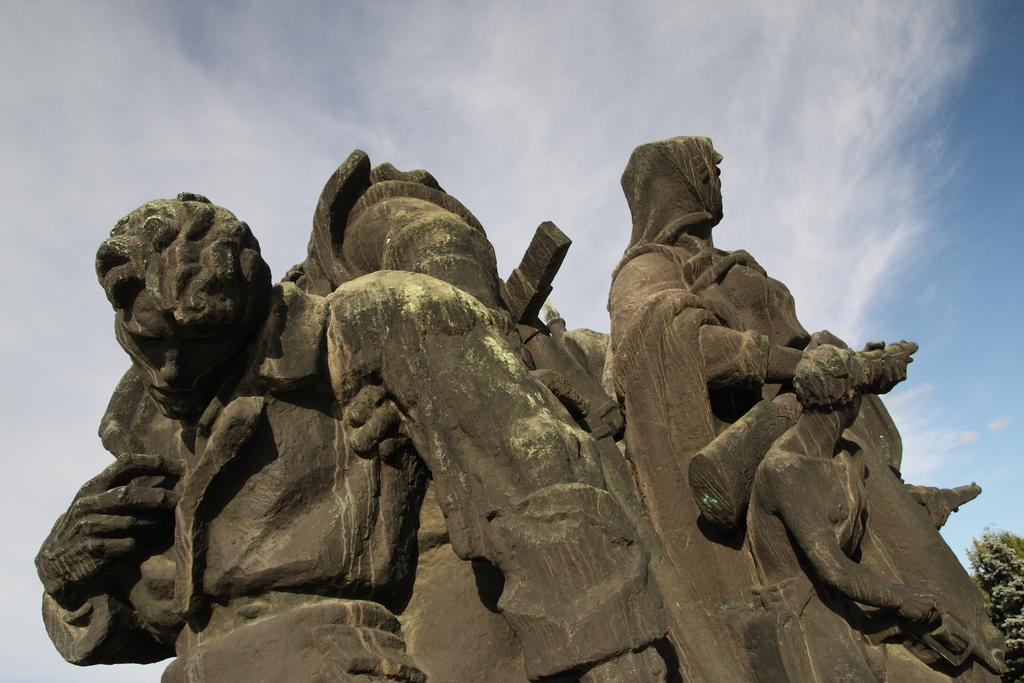What can be seen in the foreground of the image? There are sculptures in the foreground of the image. What is located on the right side of the image? There is a tree on the right side of the image. What is visible in the background of the image? The sky is visible in the background of the image. How many fangs can be seen on the sculptures in the image? There are no fangs present on the sculptures in the image. What type of parcel is being held by the hands in the image? There are no hands or parcels present in the image. 